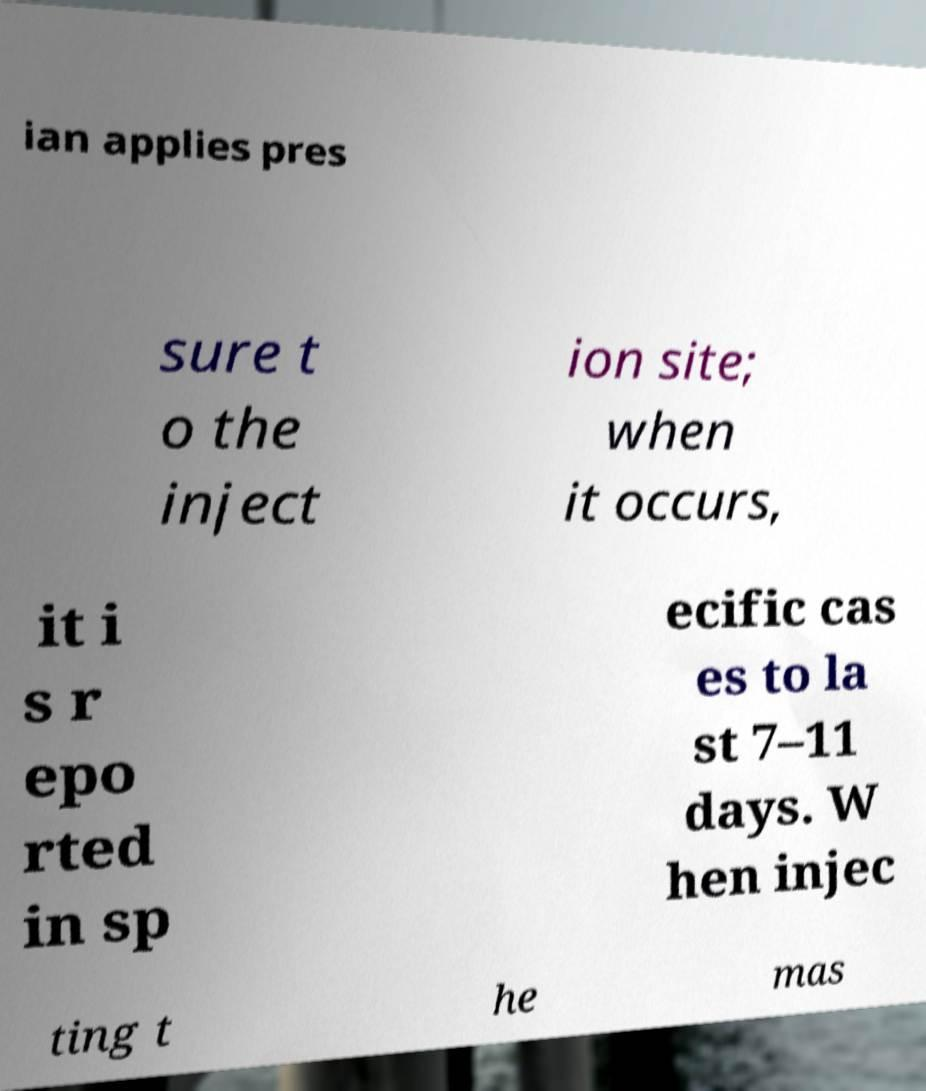There's text embedded in this image that I need extracted. Can you transcribe it verbatim? ian applies pres sure t o the inject ion site; when it occurs, it i s r epo rted in sp ecific cas es to la st 7–11 days. W hen injec ting t he mas 